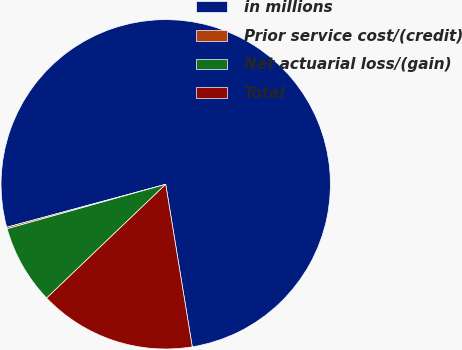<chart> <loc_0><loc_0><loc_500><loc_500><pie_chart><fcel>in millions<fcel>Prior service cost/(credit)<fcel>Net actuarial loss/(gain)<fcel>Total<nl><fcel>76.62%<fcel>0.15%<fcel>7.79%<fcel>15.44%<nl></chart> 